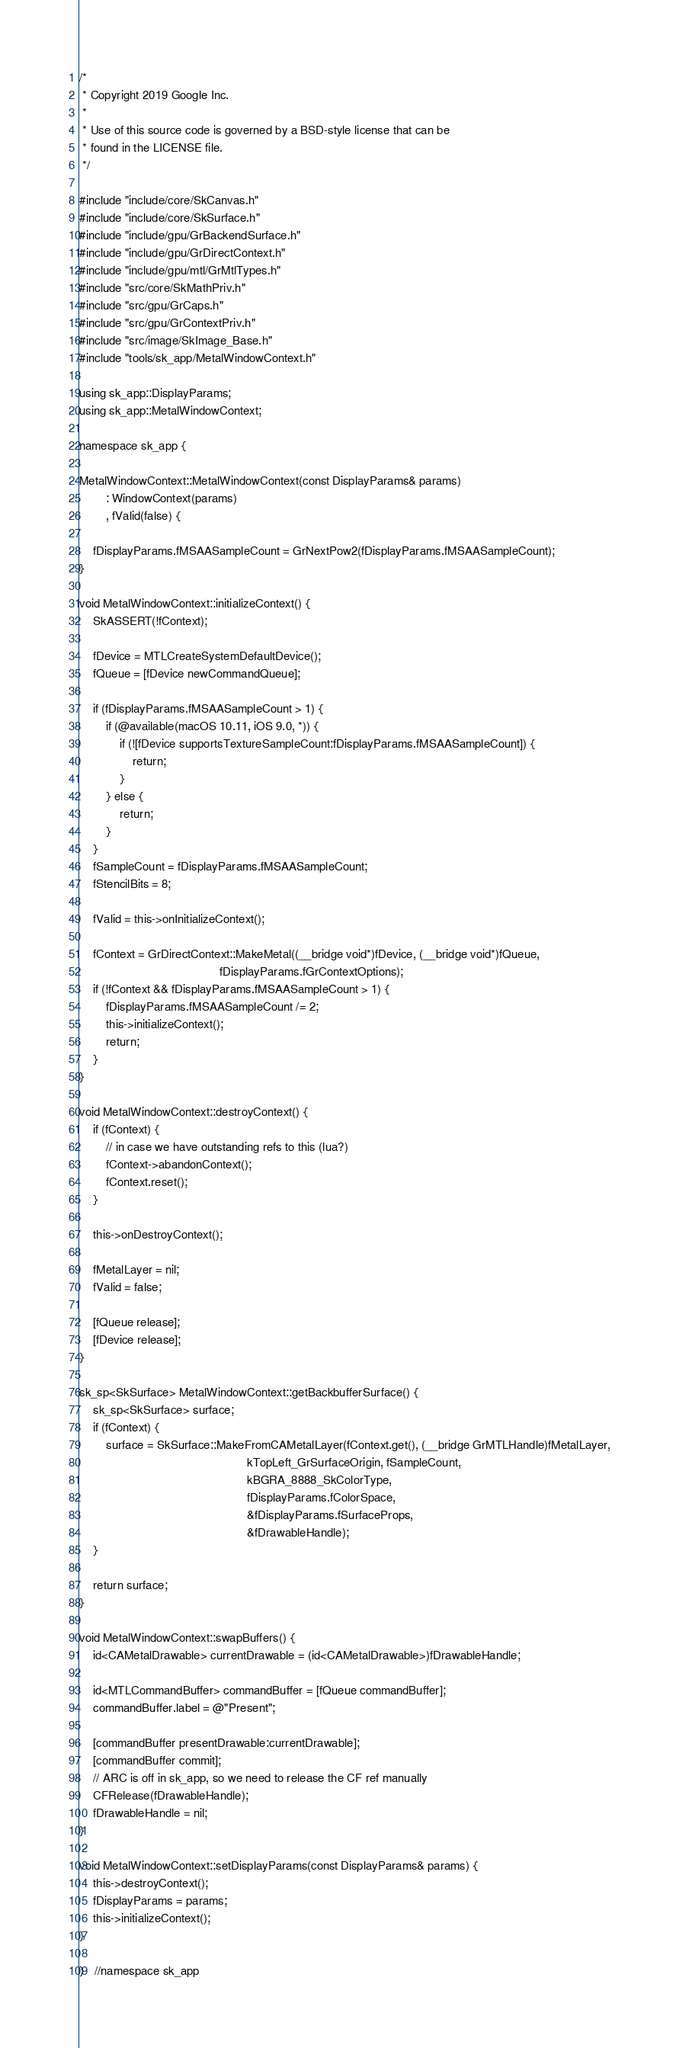Convert code to text. <code><loc_0><loc_0><loc_500><loc_500><_ObjectiveC_>/*
 * Copyright 2019 Google Inc.
 *
 * Use of this source code is governed by a BSD-style license that can be
 * found in the LICENSE file.
 */

#include "include/core/SkCanvas.h"
#include "include/core/SkSurface.h"
#include "include/gpu/GrBackendSurface.h"
#include "include/gpu/GrDirectContext.h"
#include "include/gpu/mtl/GrMtlTypes.h"
#include "src/core/SkMathPriv.h"
#include "src/gpu/GrCaps.h"
#include "src/gpu/GrContextPriv.h"
#include "src/image/SkImage_Base.h"
#include "tools/sk_app/MetalWindowContext.h"

using sk_app::DisplayParams;
using sk_app::MetalWindowContext;

namespace sk_app {

MetalWindowContext::MetalWindowContext(const DisplayParams& params)
        : WindowContext(params)
        , fValid(false) {

    fDisplayParams.fMSAASampleCount = GrNextPow2(fDisplayParams.fMSAASampleCount);
}

void MetalWindowContext::initializeContext() {
    SkASSERT(!fContext);

    fDevice = MTLCreateSystemDefaultDevice();
    fQueue = [fDevice newCommandQueue];

    if (fDisplayParams.fMSAASampleCount > 1) {
        if (@available(macOS 10.11, iOS 9.0, *)) {
            if (![fDevice supportsTextureSampleCount:fDisplayParams.fMSAASampleCount]) {
                return;
            }
        } else {
            return;
        }
    }
    fSampleCount = fDisplayParams.fMSAASampleCount;
    fStencilBits = 8;

    fValid = this->onInitializeContext();

    fContext = GrDirectContext::MakeMetal((__bridge void*)fDevice, (__bridge void*)fQueue,
                                          fDisplayParams.fGrContextOptions);
    if (!fContext && fDisplayParams.fMSAASampleCount > 1) {
        fDisplayParams.fMSAASampleCount /= 2;
        this->initializeContext();
        return;
    }
}

void MetalWindowContext::destroyContext() {
    if (fContext) {
        // in case we have outstanding refs to this (lua?)
        fContext->abandonContext();
        fContext.reset();
    }

    this->onDestroyContext();

    fMetalLayer = nil;
    fValid = false;

    [fQueue release];
    [fDevice release];
}

sk_sp<SkSurface> MetalWindowContext::getBackbufferSurface() {
    sk_sp<SkSurface> surface;
    if (fContext) {
        surface = SkSurface::MakeFromCAMetalLayer(fContext.get(), (__bridge GrMTLHandle)fMetalLayer,
                                                  kTopLeft_GrSurfaceOrigin, fSampleCount,
                                                  kBGRA_8888_SkColorType,
                                                  fDisplayParams.fColorSpace,
                                                  &fDisplayParams.fSurfaceProps,
                                                  &fDrawableHandle);
    }

    return surface;
}

void MetalWindowContext::swapBuffers() {
    id<CAMetalDrawable> currentDrawable = (id<CAMetalDrawable>)fDrawableHandle;

    id<MTLCommandBuffer> commandBuffer = [fQueue commandBuffer];
    commandBuffer.label = @"Present";

    [commandBuffer presentDrawable:currentDrawable];
    [commandBuffer commit];
    // ARC is off in sk_app, so we need to release the CF ref manually
    CFRelease(fDrawableHandle);
    fDrawableHandle = nil;
}

void MetalWindowContext::setDisplayParams(const DisplayParams& params) {
    this->destroyContext();
    fDisplayParams = params;
    this->initializeContext();
}

}   //namespace sk_app
</code> 